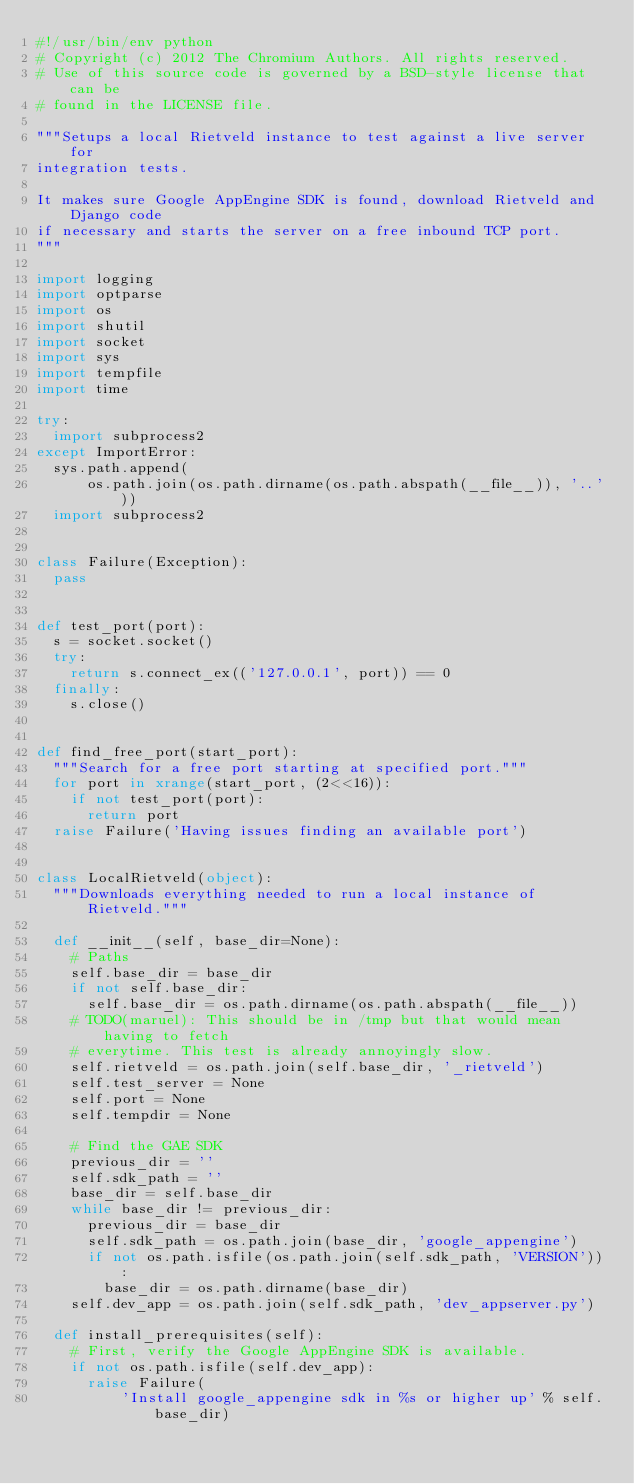Convert code to text. <code><loc_0><loc_0><loc_500><loc_500><_Python_>#!/usr/bin/env python
# Copyright (c) 2012 The Chromium Authors. All rights reserved.
# Use of this source code is governed by a BSD-style license that can be
# found in the LICENSE file.

"""Setups a local Rietveld instance to test against a live server for
integration tests.

It makes sure Google AppEngine SDK is found, download Rietveld and Django code
if necessary and starts the server on a free inbound TCP port.
"""

import logging
import optparse
import os
import shutil
import socket
import sys
import tempfile
import time

try:
  import subprocess2
except ImportError:
  sys.path.append(
      os.path.join(os.path.dirname(os.path.abspath(__file__)), '..'))
  import subprocess2


class Failure(Exception):
  pass


def test_port(port):
  s = socket.socket()
  try:
    return s.connect_ex(('127.0.0.1', port)) == 0
  finally:
    s.close()


def find_free_port(start_port):
  """Search for a free port starting at specified port."""
  for port in xrange(start_port, (2<<16)):
    if not test_port(port):
      return port
  raise Failure('Having issues finding an available port')


class LocalRietveld(object):
  """Downloads everything needed to run a local instance of Rietveld."""

  def __init__(self, base_dir=None):
    # Paths
    self.base_dir = base_dir
    if not self.base_dir:
      self.base_dir = os.path.dirname(os.path.abspath(__file__))
    # TODO(maruel): This should be in /tmp but that would mean having to fetch
    # everytime. This test is already annoyingly slow.
    self.rietveld = os.path.join(self.base_dir, '_rietveld')
    self.test_server = None
    self.port = None
    self.tempdir = None

    # Find the GAE SDK
    previous_dir = ''
    self.sdk_path = ''
    base_dir = self.base_dir
    while base_dir != previous_dir:
      previous_dir = base_dir
      self.sdk_path = os.path.join(base_dir, 'google_appengine')
      if not os.path.isfile(os.path.join(self.sdk_path, 'VERSION')):
        base_dir = os.path.dirname(base_dir)
    self.dev_app = os.path.join(self.sdk_path, 'dev_appserver.py')

  def install_prerequisites(self):
    # First, verify the Google AppEngine SDK is available.
    if not os.path.isfile(self.dev_app):
      raise Failure(
          'Install google_appengine sdk in %s or higher up' % self.base_dir)
</code> 